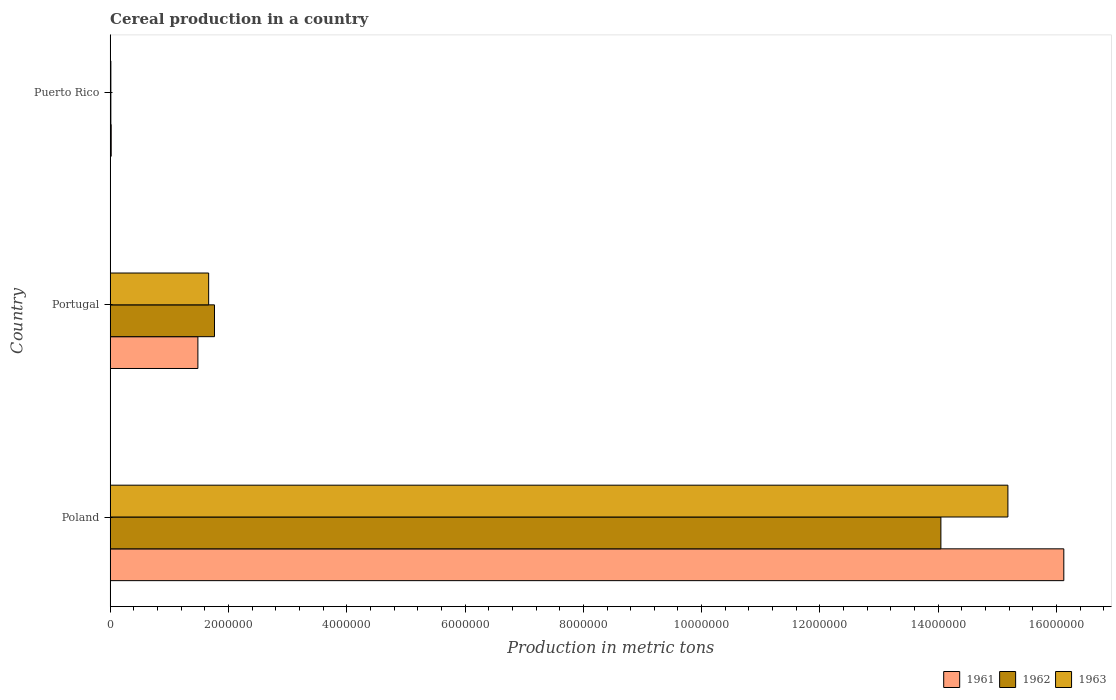How many groups of bars are there?
Your answer should be compact. 3. Are the number of bars on each tick of the Y-axis equal?
Keep it short and to the point. Yes. How many bars are there on the 3rd tick from the top?
Give a very brief answer. 3. How many bars are there on the 2nd tick from the bottom?
Provide a short and direct response. 3. What is the label of the 1st group of bars from the top?
Your answer should be compact. Puerto Rico. What is the total cereal production in 1963 in Portugal?
Your answer should be compact. 1.67e+06. Across all countries, what is the maximum total cereal production in 1962?
Provide a short and direct response. 1.40e+07. Across all countries, what is the minimum total cereal production in 1961?
Give a very brief answer. 1.80e+04. In which country was the total cereal production in 1963 maximum?
Your answer should be compact. Poland. In which country was the total cereal production in 1961 minimum?
Keep it short and to the point. Puerto Rico. What is the total total cereal production in 1963 in the graph?
Make the answer very short. 1.69e+07. What is the difference between the total cereal production in 1963 in Poland and that in Puerto Rico?
Offer a very short reply. 1.52e+07. What is the difference between the total cereal production in 1961 in Puerto Rico and the total cereal production in 1963 in Portugal?
Keep it short and to the point. -1.65e+06. What is the average total cereal production in 1962 per country?
Your answer should be very brief. 5.27e+06. What is the difference between the total cereal production in 1963 and total cereal production in 1961 in Poland?
Ensure brevity in your answer.  -9.45e+05. In how many countries, is the total cereal production in 1962 greater than 4800000 metric tons?
Ensure brevity in your answer.  1. What is the ratio of the total cereal production in 1961 in Poland to that in Portugal?
Offer a terse response. 10.87. Is the difference between the total cereal production in 1963 in Portugal and Puerto Rico greater than the difference between the total cereal production in 1961 in Portugal and Puerto Rico?
Provide a succinct answer. Yes. What is the difference between the highest and the second highest total cereal production in 1961?
Keep it short and to the point. 1.46e+07. What is the difference between the highest and the lowest total cereal production in 1962?
Offer a terse response. 1.40e+07. Is the sum of the total cereal production in 1961 in Poland and Puerto Rico greater than the maximum total cereal production in 1963 across all countries?
Your answer should be very brief. Yes. What does the 1st bar from the top in Poland represents?
Offer a terse response. 1963. How many bars are there?
Make the answer very short. 9. Are all the bars in the graph horizontal?
Give a very brief answer. Yes. What is the difference between two consecutive major ticks on the X-axis?
Offer a terse response. 2.00e+06. How many legend labels are there?
Your answer should be very brief. 3. How are the legend labels stacked?
Your answer should be compact. Horizontal. What is the title of the graph?
Provide a succinct answer. Cereal production in a country. Does "1978" appear as one of the legend labels in the graph?
Offer a terse response. No. What is the label or title of the X-axis?
Give a very brief answer. Production in metric tons. What is the label or title of the Y-axis?
Give a very brief answer. Country. What is the Production in metric tons of 1961 in Poland?
Provide a short and direct response. 1.61e+07. What is the Production in metric tons in 1962 in Poland?
Ensure brevity in your answer.  1.40e+07. What is the Production in metric tons of 1963 in Poland?
Your answer should be compact. 1.52e+07. What is the Production in metric tons of 1961 in Portugal?
Your response must be concise. 1.48e+06. What is the Production in metric tons in 1962 in Portugal?
Your answer should be very brief. 1.76e+06. What is the Production in metric tons of 1963 in Portugal?
Your answer should be compact. 1.67e+06. What is the Production in metric tons of 1961 in Puerto Rico?
Your answer should be very brief. 1.80e+04. What is the Production in metric tons of 1962 in Puerto Rico?
Keep it short and to the point. 1.20e+04. What is the Production in metric tons of 1963 in Puerto Rico?
Offer a terse response. 1.23e+04. Across all countries, what is the maximum Production in metric tons in 1961?
Offer a very short reply. 1.61e+07. Across all countries, what is the maximum Production in metric tons in 1962?
Make the answer very short. 1.40e+07. Across all countries, what is the maximum Production in metric tons of 1963?
Ensure brevity in your answer.  1.52e+07. Across all countries, what is the minimum Production in metric tons of 1961?
Give a very brief answer. 1.80e+04. Across all countries, what is the minimum Production in metric tons in 1962?
Your answer should be compact. 1.20e+04. Across all countries, what is the minimum Production in metric tons in 1963?
Make the answer very short. 1.23e+04. What is the total Production in metric tons of 1961 in the graph?
Give a very brief answer. 1.76e+07. What is the total Production in metric tons of 1962 in the graph?
Keep it short and to the point. 1.58e+07. What is the total Production in metric tons of 1963 in the graph?
Your answer should be compact. 1.69e+07. What is the difference between the Production in metric tons of 1961 in Poland and that in Portugal?
Keep it short and to the point. 1.46e+07. What is the difference between the Production in metric tons of 1962 in Poland and that in Portugal?
Offer a very short reply. 1.23e+07. What is the difference between the Production in metric tons in 1963 in Poland and that in Portugal?
Your response must be concise. 1.35e+07. What is the difference between the Production in metric tons of 1961 in Poland and that in Puerto Rico?
Your answer should be compact. 1.61e+07. What is the difference between the Production in metric tons of 1962 in Poland and that in Puerto Rico?
Make the answer very short. 1.40e+07. What is the difference between the Production in metric tons in 1963 in Poland and that in Puerto Rico?
Provide a succinct answer. 1.52e+07. What is the difference between the Production in metric tons in 1961 in Portugal and that in Puerto Rico?
Provide a short and direct response. 1.47e+06. What is the difference between the Production in metric tons in 1962 in Portugal and that in Puerto Rico?
Provide a short and direct response. 1.75e+06. What is the difference between the Production in metric tons in 1963 in Portugal and that in Puerto Rico?
Give a very brief answer. 1.65e+06. What is the difference between the Production in metric tons of 1961 in Poland and the Production in metric tons of 1962 in Portugal?
Your answer should be very brief. 1.44e+07. What is the difference between the Production in metric tons of 1961 in Poland and the Production in metric tons of 1963 in Portugal?
Provide a short and direct response. 1.45e+07. What is the difference between the Production in metric tons of 1962 in Poland and the Production in metric tons of 1963 in Portugal?
Offer a very short reply. 1.24e+07. What is the difference between the Production in metric tons in 1961 in Poland and the Production in metric tons in 1962 in Puerto Rico?
Give a very brief answer. 1.61e+07. What is the difference between the Production in metric tons of 1961 in Poland and the Production in metric tons of 1963 in Puerto Rico?
Provide a succinct answer. 1.61e+07. What is the difference between the Production in metric tons of 1962 in Poland and the Production in metric tons of 1963 in Puerto Rico?
Give a very brief answer. 1.40e+07. What is the difference between the Production in metric tons in 1961 in Portugal and the Production in metric tons in 1962 in Puerto Rico?
Your response must be concise. 1.47e+06. What is the difference between the Production in metric tons in 1961 in Portugal and the Production in metric tons in 1963 in Puerto Rico?
Give a very brief answer. 1.47e+06. What is the difference between the Production in metric tons in 1962 in Portugal and the Production in metric tons in 1963 in Puerto Rico?
Provide a succinct answer. 1.75e+06. What is the average Production in metric tons in 1961 per country?
Provide a succinct answer. 5.87e+06. What is the average Production in metric tons in 1962 per country?
Make the answer very short. 5.27e+06. What is the average Production in metric tons of 1963 per country?
Offer a terse response. 5.62e+06. What is the difference between the Production in metric tons of 1961 and Production in metric tons of 1962 in Poland?
Keep it short and to the point. 2.08e+06. What is the difference between the Production in metric tons of 1961 and Production in metric tons of 1963 in Poland?
Offer a very short reply. 9.45e+05. What is the difference between the Production in metric tons of 1962 and Production in metric tons of 1963 in Poland?
Provide a succinct answer. -1.13e+06. What is the difference between the Production in metric tons in 1961 and Production in metric tons in 1962 in Portugal?
Offer a very short reply. -2.81e+05. What is the difference between the Production in metric tons of 1961 and Production in metric tons of 1963 in Portugal?
Offer a terse response. -1.82e+05. What is the difference between the Production in metric tons in 1962 and Production in metric tons in 1963 in Portugal?
Provide a short and direct response. 9.87e+04. What is the difference between the Production in metric tons in 1961 and Production in metric tons in 1962 in Puerto Rico?
Offer a terse response. 5933. What is the difference between the Production in metric tons of 1961 and Production in metric tons of 1963 in Puerto Rico?
Offer a terse response. 5633. What is the difference between the Production in metric tons in 1962 and Production in metric tons in 1963 in Puerto Rico?
Your answer should be compact. -300. What is the ratio of the Production in metric tons of 1961 in Poland to that in Portugal?
Give a very brief answer. 10.87. What is the ratio of the Production in metric tons in 1962 in Poland to that in Portugal?
Offer a terse response. 7.96. What is the ratio of the Production in metric tons in 1963 in Poland to that in Portugal?
Offer a very short reply. 9.11. What is the ratio of the Production in metric tons in 1961 in Poland to that in Puerto Rico?
Provide a short and direct response. 896.62. What is the ratio of the Production in metric tons in 1962 in Poland to that in Puerto Rico?
Keep it short and to the point. 1165.66. What is the ratio of the Production in metric tons of 1963 in Poland to that in Puerto Rico?
Give a very brief answer. 1229.09. What is the ratio of the Production in metric tons in 1961 in Portugal to that in Puerto Rico?
Your answer should be compact. 82.49. What is the ratio of the Production in metric tons of 1962 in Portugal to that in Puerto Rico?
Ensure brevity in your answer.  146.4. What is the ratio of the Production in metric tons in 1963 in Portugal to that in Puerto Rico?
Offer a terse response. 134.85. What is the difference between the highest and the second highest Production in metric tons in 1961?
Keep it short and to the point. 1.46e+07. What is the difference between the highest and the second highest Production in metric tons in 1962?
Provide a short and direct response. 1.23e+07. What is the difference between the highest and the second highest Production in metric tons of 1963?
Your answer should be very brief. 1.35e+07. What is the difference between the highest and the lowest Production in metric tons of 1961?
Give a very brief answer. 1.61e+07. What is the difference between the highest and the lowest Production in metric tons of 1962?
Make the answer very short. 1.40e+07. What is the difference between the highest and the lowest Production in metric tons of 1963?
Provide a short and direct response. 1.52e+07. 